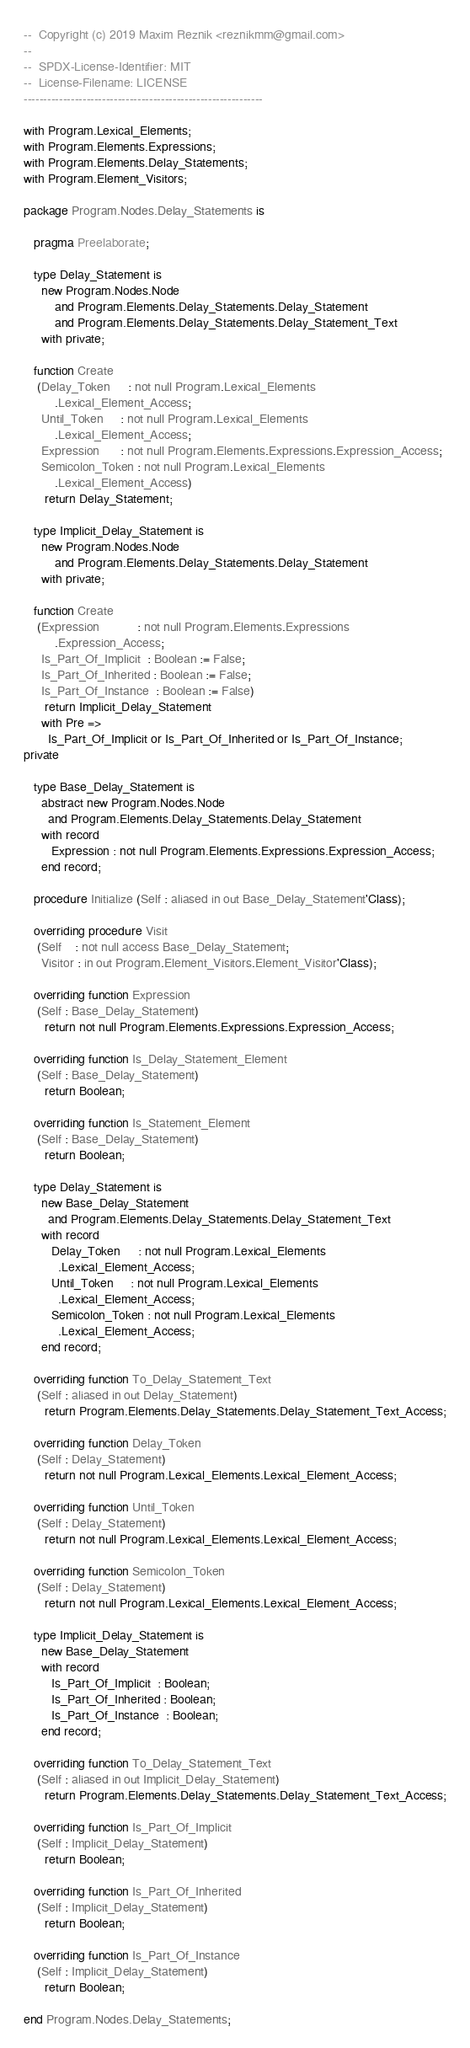<code> <loc_0><loc_0><loc_500><loc_500><_Ada_>--  Copyright (c) 2019 Maxim Reznik <reznikmm@gmail.com>
--
--  SPDX-License-Identifier: MIT
--  License-Filename: LICENSE
-------------------------------------------------------------

with Program.Lexical_Elements;
with Program.Elements.Expressions;
with Program.Elements.Delay_Statements;
with Program.Element_Visitors;

package Program.Nodes.Delay_Statements is

   pragma Preelaborate;

   type Delay_Statement is
     new Program.Nodes.Node
         and Program.Elements.Delay_Statements.Delay_Statement
         and Program.Elements.Delay_Statements.Delay_Statement_Text
     with private;

   function Create
    (Delay_Token     : not null Program.Lexical_Elements
         .Lexical_Element_Access;
     Until_Token     : not null Program.Lexical_Elements
         .Lexical_Element_Access;
     Expression      : not null Program.Elements.Expressions.Expression_Access;
     Semicolon_Token : not null Program.Lexical_Elements
         .Lexical_Element_Access)
      return Delay_Statement;

   type Implicit_Delay_Statement is
     new Program.Nodes.Node
         and Program.Elements.Delay_Statements.Delay_Statement
     with private;

   function Create
    (Expression           : not null Program.Elements.Expressions
         .Expression_Access;
     Is_Part_Of_Implicit  : Boolean := False;
     Is_Part_Of_Inherited : Boolean := False;
     Is_Part_Of_Instance  : Boolean := False)
      return Implicit_Delay_Statement
     with Pre =>
       Is_Part_Of_Implicit or Is_Part_Of_Inherited or Is_Part_Of_Instance;
private

   type Base_Delay_Statement is
     abstract new Program.Nodes.Node
       and Program.Elements.Delay_Statements.Delay_Statement
     with record
        Expression : not null Program.Elements.Expressions.Expression_Access;
     end record;

   procedure Initialize (Self : aliased in out Base_Delay_Statement'Class);

   overriding procedure Visit
    (Self    : not null access Base_Delay_Statement;
     Visitor : in out Program.Element_Visitors.Element_Visitor'Class);

   overriding function Expression
    (Self : Base_Delay_Statement)
      return not null Program.Elements.Expressions.Expression_Access;

   overriding function Is_Delay_Statement_Element
    (Self : Base_Delay_Statement)
      return Boolean;

   overriding function Is_Statement_Element
    (Self : Base_Delay_Statement)
      return Boolean;

   type Delay_Statement is
     new Base_Delay_Statement
       and Program.Elements.Delay_Statements.Delay_Statement_Text
     with record
        Delay_Token     : not null Program.Lexical_Elements
          .Lexical_Element_Access;
        Until_Token     : not null Program.Lexical_Elements
          .Lexical_Element_Access;
        Semicolon_Token : not null Program.Lexical_Elements
          .Lexical_Element_Access;
     end record;

   overriding function To_Delay_Statement_Text
    (Self : aliased in out Delay_Statement)
      return Program.Elements.Delay_Statements.Delay_Statement_Text_Access;

   overriding function Delay_Token
    (Self : Delay_Statement)
      return not null Program.Lexical_Elements.Lexical_Element_Access;

   overriding function Until_Token
    (Self : Delay_Statement)
      return not null Program.Lexical_Elements.Lexical_Element_Access;

   overriding function Semicolon_Token
    (Self : Delay_Statement)
      return not null Program.Lexical_Elements.Lexical_Element_Access;

   type Implicit_Delay_Statement is
     new Base_Delay_Statement
     with record
        Is_Part_Of_Implicit  : Boolean;
        Is_Part_Of_Inherited : Boolean;
        Is_Part_Of_Instance  : Boolean;
     end record;

   overriding function To_Delay_Statement_Text
    (Self : aliased in out Implicit_Delay_Statement)
      return Program.Elements.Delay_Statements.Delay_Statement_Text_Access;

   overriding function Is_Part_Of_Implicit
    (Self : Implicit_Delay_Statement)
      return Boolean;

   overriding function Is_Part_Of_Inherited
    (Self : Implicit_Delay_Statement)
      return Boolean;

   overriding function Is_Part_Of_Instance
    (Self : Implicit_Delay_Statement)
      return Boolean;

end Program.Nodes.Delay_Statements;
</code> 